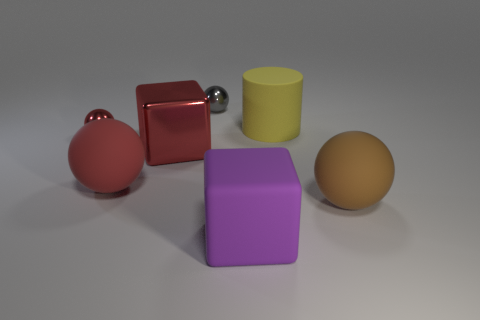What sort of material properties can you infer from the objects shown in the scene? The materials seem to be a mixture of matte and reflective surfaces. The red cube and the yellow cylinder display a matte finish, which scatters light and gives the objects a soft appearance. On the contrary, the silver sphere has a high-gloss, reflective surface that mirrors its surroundings, suggesting it could be made of a polished metal. The purple block also has a slightly reflective surface, but its luster is less intense compared to the silver sphere, which might indicate a plastic material with a semi-gloss finish. The tan sphere presents with a subdued reflection, hinting at a material quality between matte and semi-gloss, possibly a sanded wood or a matte plastic.  How could this image be used in an educational context? This image could be used as a visual aid in various educational settings. For example, in a physics lesson on light and reflection, the image can help illustrate how different surfaces reflect light. For art and design students, it can serve as a basis for discussions on composition, color theory, and the emotional impact of different hues and shapes. In a geometry class, the image may be used to help identify different geometric solids and to demonstrate the concepts of volume and surface area. The image can also facilitate a conversation on material properties in a science class, where students can hypothesize about the materials based on the visual cues. 